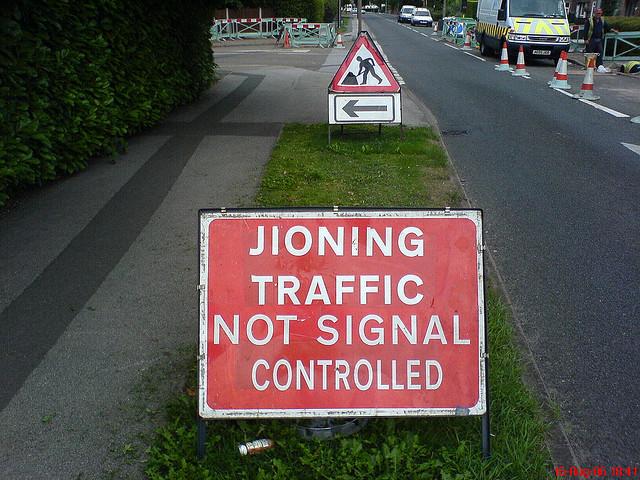Is the traffic signal controlled?
Write a very short answer. No. What does the triangle traffic sign mean?
Give a very brief answer. Men at work. What direction is the arrow pointing?
Give a very brief answer. Left. 